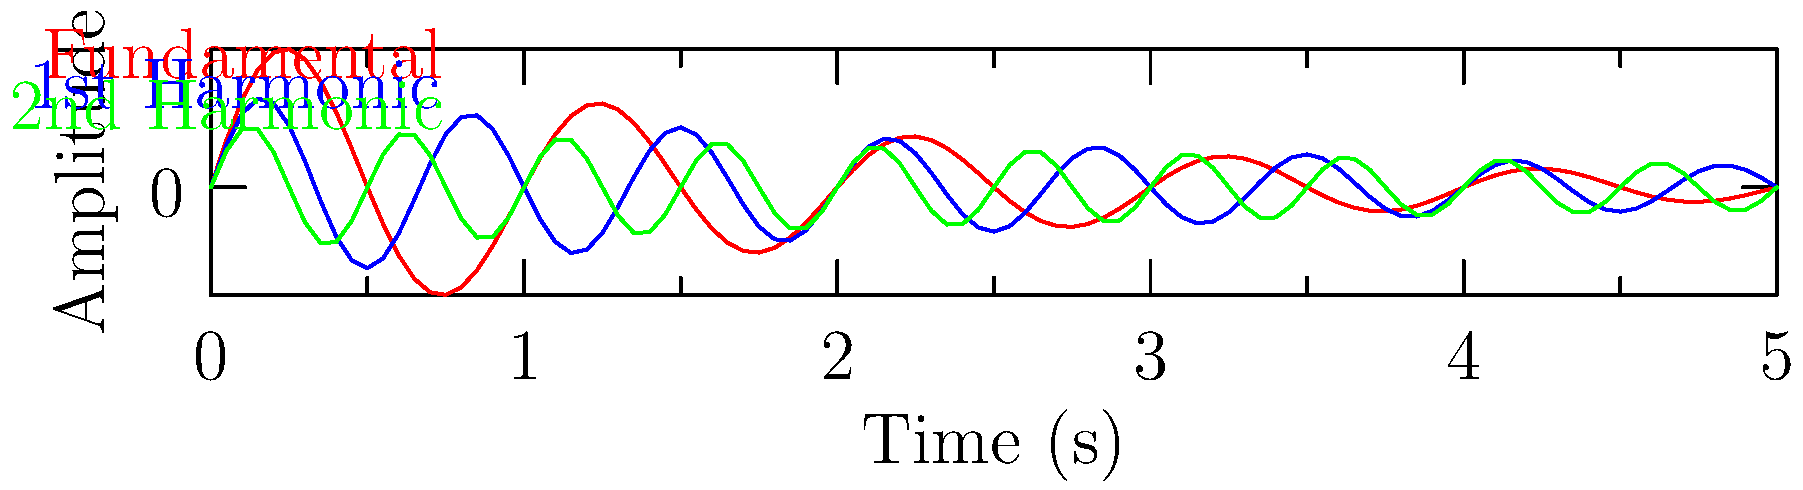As a record label owner specializing in classic metal reissues, you're analyzing the frequency spectrum of a guitar riff. The graph shows three components of the sound wave: the fundamental frequency (red), first harmonic (blue), and second harmonic (green). If the fundamental frequency is 220 Hz (A3 note), what is the frequency of the second harmonic (green line)? To determine the frequency of the second harmonic, we need to understand the relationship between harmonics and the fundamental frequency:

1. The fundamental frequency is the lowest and strongest frequency in a complex sound, represented by the red line (220 Hz).

2. Harmonics are integer multiples of the fundamental frequency:
   - 1st harmonic = 2 × fundamental
   - 2nd harmonic = 3 × fundamental
   - 3rd harmonic = 4 × fundamental, and so on

3. In this case:
   - Fundamental (red) = 220 Hz
   - 1st harmonic (blue) = 2 × 220 Hz = 440 Hz
   - 2nd harmonic (green) = 3 × 220 Hz = 660 Hz

4. Therefore, the frequency of the second harmonic (green line) is 660 Hz.

This understanding is crucial for audio engineers and producers working with classic metal recordings, as it helps in EQ adjustments, mixing, and mastering for optimal vinyl playback.
Answer: 660 Hz 